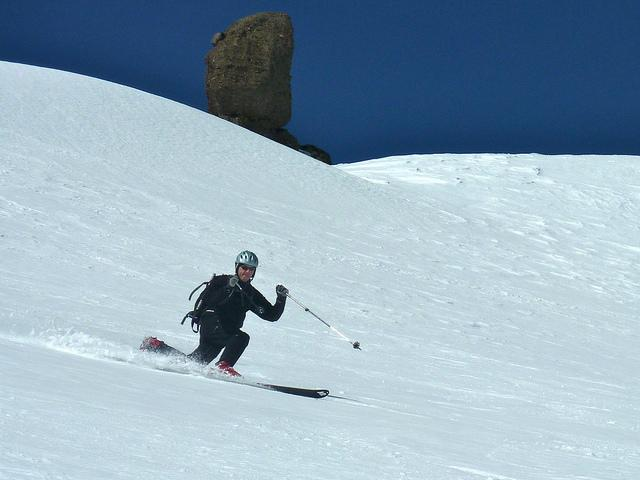Why is the man wearing the silver helmet? Please explain your reasoning. safety. He is skiing. the helmet protects his head. 